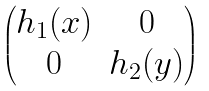<formula> <loc_0><loc_0><loc_500><loc_500>\begin{pmatrix} h _ { 1 } ( x ) & 0 \\ 0 & h _ { 2 } ( y ) \end{pmatrix}</formula> 